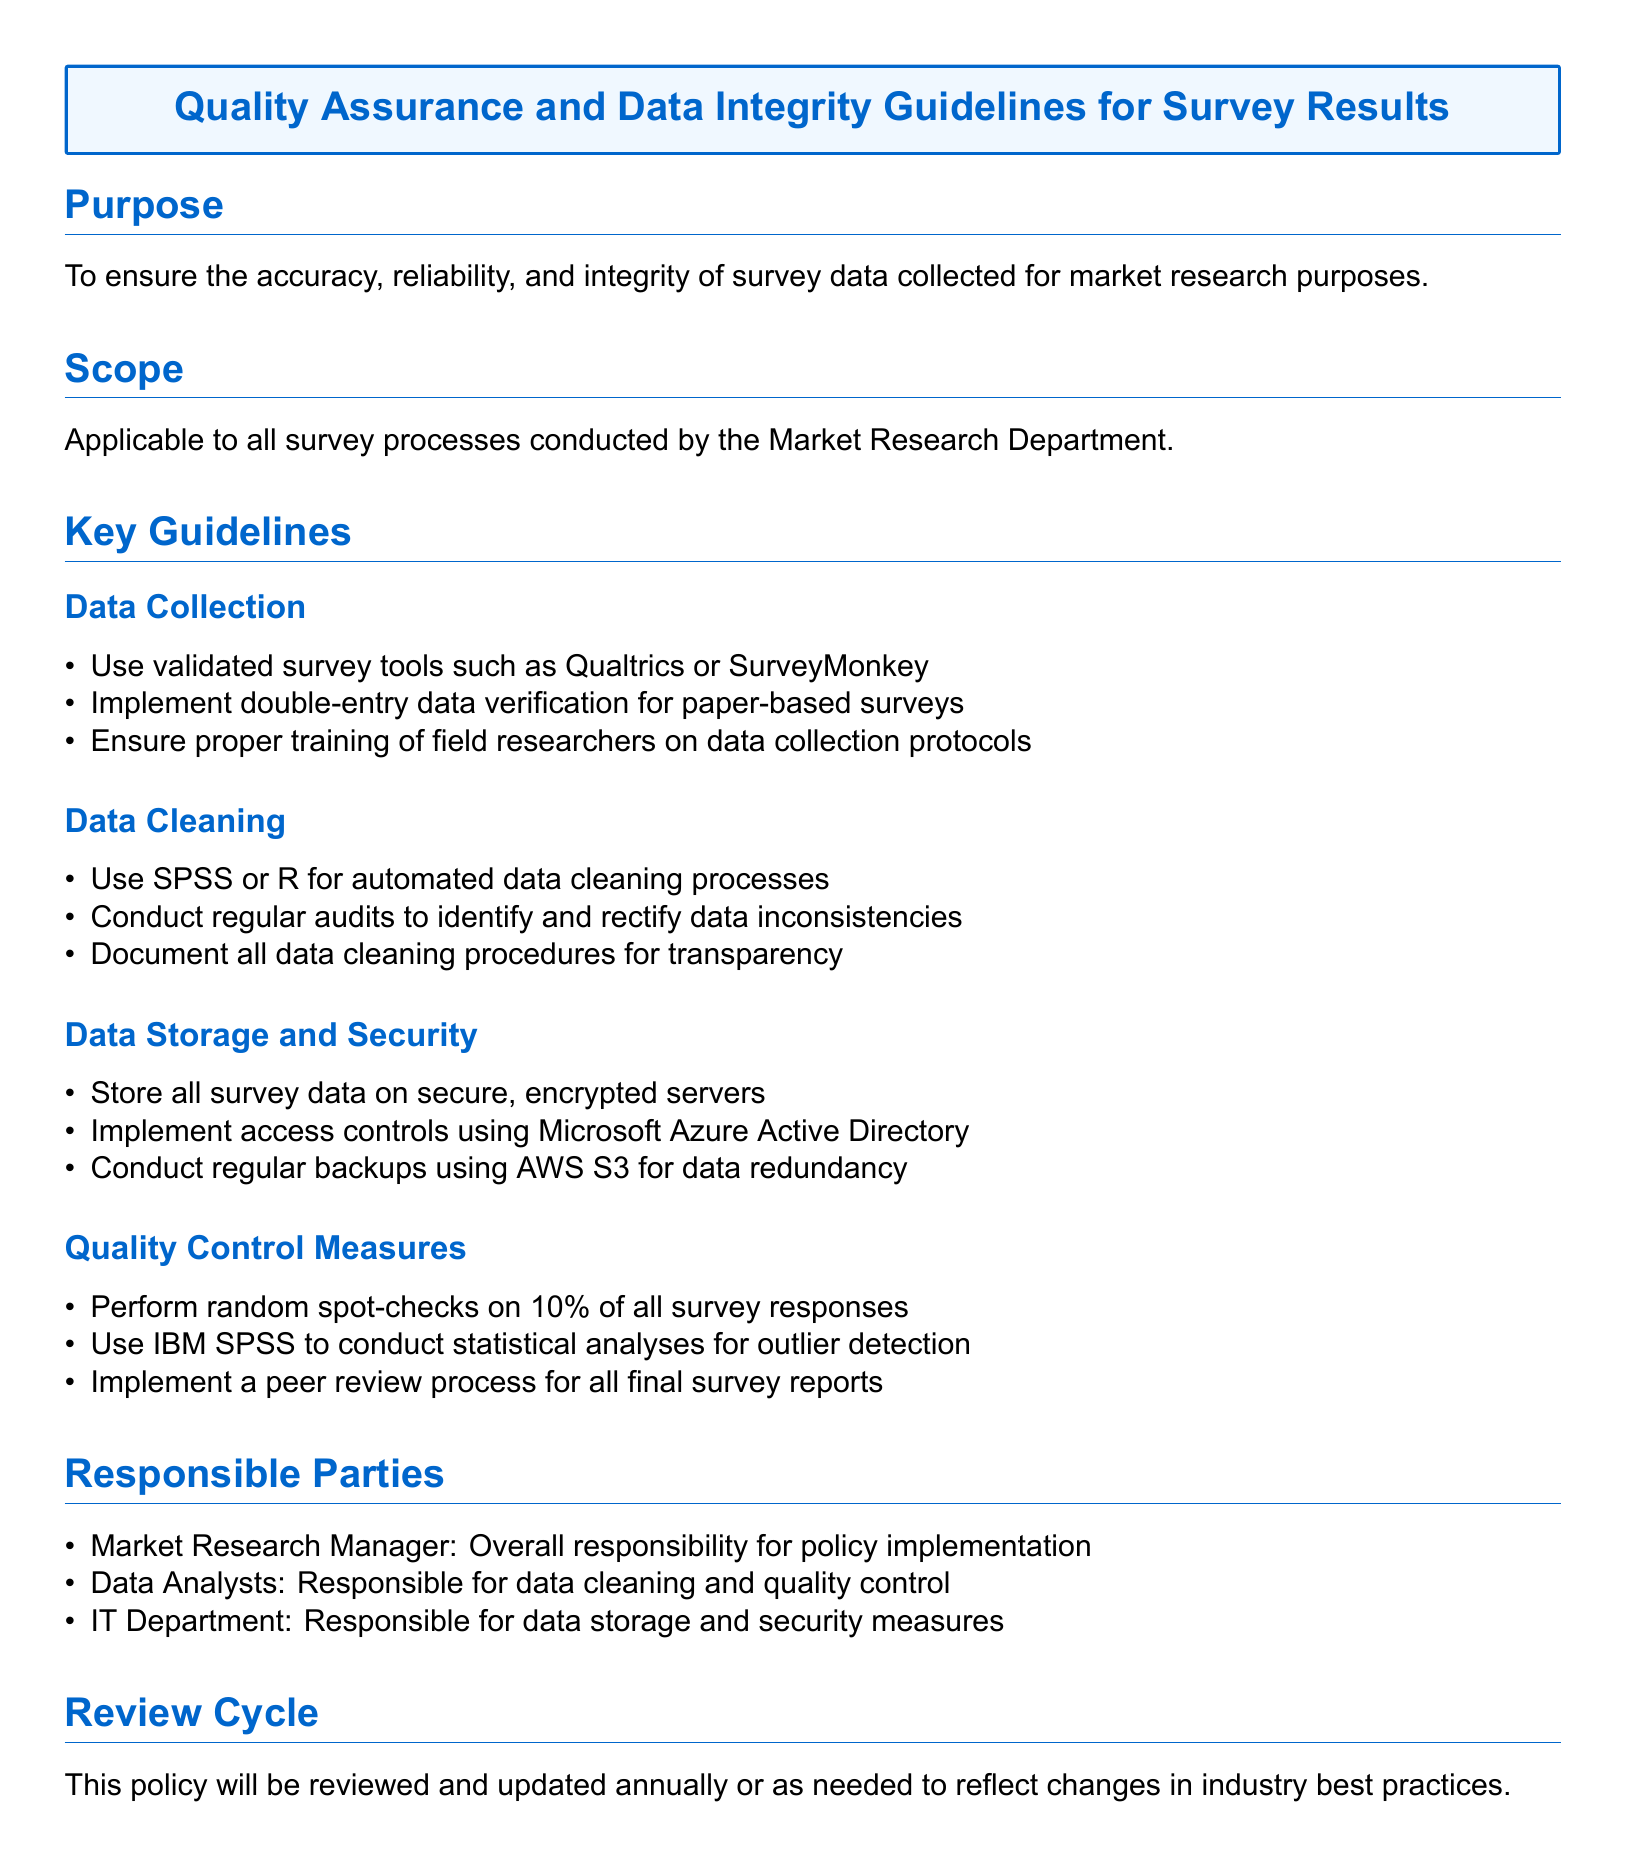What is the purpose of the guidelines? The purpose is to ensure the accuracy, reliability, and integrity of survey data collected for market research purposes.
Answer: To ensure the accuracy, reliability, and integrity of survey data Who is responsible for policy implementation? The Market Research Manager has overall responsibility for implementing the policy as mentioned in the document.
Answer: Market Research Manager What percentage of survey responses are subject to random spot-checks? The document specifies that random spot-checks are conducted on 10% of all survey responses.
Answer: 10% What tools are suggested for data cleaning? The guidelines recommend using SPSS or R for automated data cleaning processes as part of the data cleaning section.
Answer: SPSS or R What should be documented for transparency in data cleaning? The document states that all data cleaning procedures should be documented for transparency.
Answer: All data cleaning procedures What is the review cycle for this policy? The document mentions that this policy will be reviewed and updated annually or as needed.
Answer: Annually 